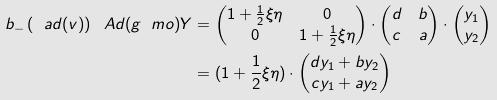Convert formula to latex. <formula><loc_0><loc_0><loc_500><loc_500>b _ { - } \left ( \ a d ( v ) \right ) \ A d ( g \ m o ) Y & = \begin{pmatrix} 1 + \frac { 1 } { 2 } \xi \eta & 0 \\ 0 & 1 + \frac { 1 } { 2 } \xi \eta \end{pmatrix} \cdot \begin{pmatrix} d & b \\ c & a \end{pmatrix} \cdot \begin{pmatrix} y _ { 1 } \\ y _ { 2 } \end{pmatrix} \\ & = ( 1 + \frac { 1 } { 2 } \xi \eta ) \cdot \begin{pmatrix} d y _ { 1 } + b y _ { 2 } \\ c y _ { 1 } + a y _ { 2 } \end{pmatrix}</formula> 